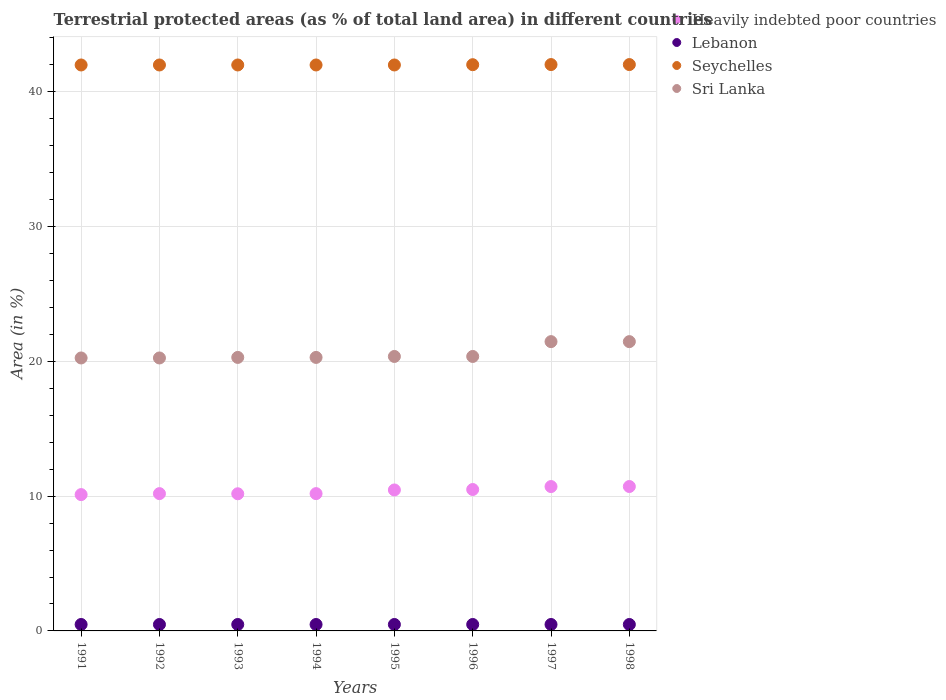Is the number of dotlines equal to the number of legend labels?
Give a very brief answer. Yes. What is the percentage of terrestrial protected land in Lebanon in 1993?
Ensure brevity in your answer.  0.48. Across all years, what is the maximum percentage of terrestrial protected land in Lebanon?
Give a very brief answer. 0.48. Across all years, what is the minimum percentage of terrestrial protected land in Lebanon?
Your answer should be compact. 0.48. In which year was the percentage of terrestrial protected land in Seychelles maximum?
Your response must be concise. 1997. What is the total percentage of terrestrial protected land in Sri Lanka in the graph?
Your response must be concise. 164.75. What is the difference between the percentage of terrestrial protected land in Lebanon in 1994 and that in 1996?
Make the answer very short. 0. What is the difference between the percentage of terrestrial protected land in Seychelles in 1993 and the percentage of terrestrial protected land in Lebanon in 1996?
Offer a very short reply. 41.51. What is the average percentage of terrestrial protected land in Lebanon per year?
Make the answer very short. 0.48. In the year 1993, what is the difference between the percentage of terrestrial protected land in Sri Lanka and percentage of terrestrial protected land in Seychelles?
Your answer should be compact. -21.7. In how many years, is the percentage of terrestrial protected land in Lebanon greater than 36 %?
Make the answer very short. 0. What is the ratio of the percentage of terrestrial protected land in Heavily indebted poor countries in 1992 to that in 1993?
Your answer should be very brief. 1. Is the difference between the percentage of terrestrial protected land in Sri Lanka in 1994 and 1995 greater than the difference between the percentage of terrestrial protected land in Seychelles in 1994 and 1995?
Offer a terse response. No. What is the difference between the highest and the second highest percentage of terrestrial protected land in Heavily indebted poor countries?
Your answer should be compact. 0. Is the sum of the percentage of terrestrial protected land in Sri Lanka in 1992 and 1997 greater than the maximum percentage of terrestrial protected land in Lebanon across all years?
Provide a short and direct response. Yes. Is it the case that in every year, the sum of the percentage of terrestrial protected land in Sri Lanka and percentage of terrestrial protected land in Heavily indebted poor countries  is greater than the percentage of terrestrial protected land in Seychelles?
Your answer should be very brief. No. Is the percentage of terrestrial protected land in Seychelles strictly greater than the percentage of terrestrial protected land in Heavily indebted poor countries over the years?
Ensure brevity in your answer.  Yes. How many years are there in the graph?
Keep it short and to the point. 8. What is the difference between two consecutive major ticks on the Y-axis?
Offer a very short reply. 10. How many legend labels are there?
Provide a short and direct response. 4. How are the legend labels stacked?
Offer a terse response. Vertical. What is the title of the graph?
Provide a short and direct response. Terrestrial protected areas (as % of total land area) in different countries. Does "Malawi" appear as one of the legend labels in the graph?
Your answer should be compact. No. What is the label or title of the Y-axis?
Provide a short and direct response. Area (in %). What is the Area (in %) of Heavily indebted poor countries in 1991?
Offer a very short reply. 10.11. What is the Area (in %) of Lebanon in 1991?
Your answer should be very brief. 0.48. What is the Area (in %) in Seychelles in 1991?
Offer a very short reply. 41.99. What is the Area (in %) in Sri Lanka in 1991?
Provide a short and direct response. 20.25. What is the Area (in %) of Heavily indebted poor countries in 1992?
Keep it short and to the point. 10.19. What is the Area (in %) in Lebanon in 1992?
Provide a succinct answer. 0.48. What is the Area (in %) in Seychelles in 1992?
Your answer should be compact. 41.99. What is the Area (in %) in Sri Lanka in 1992?
Offer a very short reply. 20.25. What is the Area (in %) in Heavily indebted poor countries in 1993?
Provide a succinct answer. 10.18. What is the Area (in %) of Lebanon in 1993?
Keep it short and to the point. 0.48. What is the Area (in %) in Seychelles in 1993?
Give a very brief answer. 41.99. What is the Area (in %) of Sri Lanka in 1993?
Your answer should be compact. 20.29. What is the Area (in %) in Heavily indebted poor countries in 1994?
Give a very brief answer. 10.19. What is the Area (in %) of Lebanon in 1994?
Your answer should be compact. 0.48. What is the Area (in %) of Seychelles in 1994?
Make the answer very short. 41.99. What is the Area (in %) of Sri Lanka in 1994?
Offer a terse response. 20.29. What is the Area (in %) of Heavily indebted poor countries in 1995?
Provide a short and direct response. 10.46. What is the Area (in %) of Lebanon in 1995?
Offer a terse response. 0.48. What is the Area (in %) in Seychelles in 1995?
Provide a succinct answer. 41.99. What is the Area (in %) in Sri Lanka in 1995?
Make the answer very short. 20.36. What is the Area (in %) in Heavily indebted poor countries in 1996?
Offer a very short reply. 10.49. What is the Area (in %) in Lebanon in 1996?
Offer a very short reply. 0.48. What is the Area (in %) in Seychelles in 1996?
Your response must be concise. 42.01. What is the Area (in %) of Sri Lanka in 1996?
Your answer should be very brief. 20.36. What is the Area (in %) of Heavily indebted poor countries in 1997?
Offer a very short reply. 10.71. What is the Area (in %) of Lebanon in 1997?
Offer a terse response. 0.48. What is the Area (in %) of Seychelles in 1997?
Ensure brevity in your answer.  42.02. What is the Area (in %) of Sri Lanka in 1997?
Make the answer very short. 21.46. What is the Area (in %) of Heavily indebted poor countries in 1998?
Provide a short and direct response. 10.71. What is the Area (in %) in Lebanon in 1998?
Offer a very short reply. 0.48. What is the Area (in %) of Seychelles in 1998?
Make the answer very short. 42.02. What is the Area (in %) of Sri Lanka in 1998?
Provide a short and direct response. 21.46. Across all years, what is the maximum Area (in %) in Heavily indebted poor countries?
Provide a succinct answer. 10.71. Across all years, what is the maximum Area (in %) of Lebanon?
Ensure brevity in your answer.  0.48. Across all years, what is the maximum Area (in %) of Seychelles?
Offer a terse response. 42.02. Across all years, what is the maximum Area (in %) in Sri Lanka?
Your response must be concise. 21.46. Across all years, what is the minimum Area (in %) of Heavily indebted poor countries?
Make the answer very short. 10.11. Across all years, what is the minimum Area (in %) of Lebanon?
Ensure brevity in your answer.  0.48. Across all years, what is the minimum Area (in %) in Seychelles?
Give a very brief answer. 41.99. Across all years, what is the minimum Area (in %) of Sri Lanka?
Your answer should be very brief. 20.25. What is the total Area (in %) of Heavily indebted poor countries in the graph?
Make the answer very short. 83.04. What is the total Area (in %) of Lebanon in the graph?
Ensure brevity in your answer.  3.82. What is the total Area (in %) of Seychelles in the graph?
Make the answer very short. 336.02. What is the total Area (in %) of Sri Lanka in the graph?
Ensure brevity in your answer.  164.75. What is the difference between the Area (in %) of Heavily indebted poor countries in 1991 and that in 1992?
Offer a terse response. -0.07. What is the difference between the Area (in %) in Heavily indebted poor countries in 1991 and that in 1993?
Offer a terse response. -0.06. What is the difference between the Area (in %) in Sri Lanka in 1991 and that in 1993?
Offer a very short reply. -0.04. What is the difference between the Area (in %) of Heavily indebted poor countries in 1991 and that in 1994?
Offer a terse response. -0.07. What is the difference between the Area (in %) of Lebanon in 1991 and that in 1994?
Give a very brief answer. 0. What is the difference between the Area (in %) of Seychelles in 1991 and that in 1994?
Your response must be concise. 0. What is the difference between the Area (in %) of Sri Lanka in 1991 and that in 1994?
Offer a terse response. -0.04. What is the difference between the Area (in %) of Heavily indebted poor countries in 1991 and that in 1995?
Ensure brevity in your answer.  -0.35. What is the difference between the Area (in %) in Seychelles in 1991 and that in 1995?
Offer a terse response. 0. What is the difference between the Area (in %) in Sri Lanka in 1991 and that in 1995?
Give a very brief answer. -0.11. What is the difference between the Area (in %) of Heavily indebted poor countries in 1991 and that in 1996?
Make the answer very short. -0.38. What is the difference between the Area (in %) in Seychelles in 1991 and that in 1996?
Provide a succinct answer. -0.02. What is the difference between the Area (in %) of Sri Lanka in 1991 and that in 1996?
Make the answer very short. -0.11. What is the difference between the Area (in %) in Heavily indebted poor countries in 1991 and that in 1997?
Provide a short and direct response. -0.6. What is the difference between the Area (in %) in Lebanon in 1991 and that in 1997?
Give a very brief answer. 0. What is the difference between the Area (in %) of Seychelles in 1991 and that in 1997?
Give a very brief answer. -0.03. What is the difference between the Area (in %) in Sri Lanka in 1991 and that in 1997?
Your response must be concise. -1.21. What is the difference between the Area (in %) of Lebanon in 1991 and that in 1998?
Your answer should be very brief. 0. What is the difference between the Area (in %) in Seychelles in 1991 and that in 1998?
Give a very brief answer. -0.03. What is the difference between the Area (in %) in Sri Lanka in 1991 and that in 1998?
Your response must be concise. -1.21. What is the difference between the Area (in %) of Heavily indebted poor countries in 1992 and that in 1993?
Make the answer very short. 0.01. What is the difference between the Area (in %) of Lebanon in 1992 and that in 1993?
Provide a short and direct response. 0. What is the difference between the Area (in %) of Seychelles in 1992 and that in 1993?
Your answer should be compact. 0. What is the difference between the Area (in %) in Sri Lanka in 1992 and that in 1993?
Provide a succinct answer. -0.04. What is the difference between the Area (in %) in Lebanon in 1992 and that in 1994?
Make the answer very short. 0. What is the difference between the Area (in %) in Seychelles in 1992 and that in 1994?
Your answer should be very brief. 0. What is the difference between the Area (in %) of Sri Lanka in 1992 and that in 1994?
Give a very brief answer. -0.04. What is the difference between the Area (in %) of Heavily indebted poor countries in 1992 and that in 1995?
Make the answer very short. -0.27. What is the difference between the Area (in %) in Lebanon in 1992 and that in 1995?
Provide a short and direct response. 0. What is the difference between the Area (in %) in Seychelles in 1992 and that in 1995?
Ensure brevity in your answer.  0. What is the difference between the Area (in %) in Sri Lanka in 1992 and that in 1995?
Offer a terse response. -0.11. What is the difference between the Area (in %) of Heavily indebted poor countries in 1992 and that in 1996?
Offer a very short reply. -0.3. What is the difference between the Area (in %) in Seychelles in 1992 and that in 1996?
Your answer should be compact. -0.02. What is the difference between the Area (in %) of Sri Lanka in 1992 and that in 1996?
Your answer should be compact. -0.11. What is the difference between the Area (in %) of Heavily indebted poor countries in 1992 and that in 1997?
Keep it short and to the point. -0.52. What is the difference between the Area (in %) of Seychelles in 1992 and that in 1997?
Offer a very short reply. -0.03. What is the difference between the Area (in %) in Sri Lanka in 1992 and that in 1997?
Provide a short and direct response. -1.21. What is the difference between the Area (in %) in Heavily indebted poor countries in 1992 and that in 1998?
Your answer should be compact. -0.53. What is the difference between the Area (in %) in Lebanon in 1992 and that in 1998?
Offer a terse response. 0. What is the difference between the Area (in %) of Seychelles in 1992 and that in 1998?
Provide a succinct answer. -0.03. What is the difference between the Area (in %) of Sri Lanka in 1992 and that in 1998?
Make the answer very short. -1.21. What is the difference between the Area (in %) in Heavily indebted poor countries in 1993 and that in 1994?
Provide a succinct answer. -0.01. What is the difference between the Area (in %) in Lebanon in 1993 and that in 1994?
Provide a short and direct response. 0. What is the difference between the Area (in %) in Seychelles in 1993 and that in 1994?
Keep it short and to the point. 0. What is the difference between the Area (in %) in Heavily indebted poor countries in 1993 and that in 1995?
Your answer should be compact. -0.28. What is the difference between the Area (in %) in Sri Lanka in 1993 and that in 1995?
Ensure brevity in your answer.  -0.07. What is the difference between the Area (in %) in Heavily indebted poor countries in 1993 and that in 1996?
Make the answer very short. -0.32. What is the difference between the Area (in %) in Seychelles in 1993 and that in 1996?
Keep it short and to the point. -0.02. What is the difference between the Area (in %) in Sri Lanka in 1993 and that in 1996?
Provide a short and direct response. -0.07. What is the difference between the Area (in %) in Heavily indebted poor countries in 1993 and that in 1997?
Offer a very short reply. -0.54. What is the difference between the Area (in %) of Lebanon in 1993 and that in 1997?
Make the answer very short. 0. What is the difference between the Area (in %) of Seychelles in 1993 and that in 1997?
Your response must be concise. -0.03. What is the difference between the Area (in %) of Sri Lanka in 1993 and that in 1997?
Ensure brevity in your answer.  -1.17. What is the difference between the Area (in %) of Heavily indebted poor countries in 1993 and that in 1998?
Provide a short and direct response. -0.54. What is the difference between the Area (in %) of Seychelles in 1993 and that in 1998?
Your response must be concise. -0.03. What is the difference between the Area (in %) in Sri Lanka in 1993 and that in 1998?
Your answer should be compact. -1.17. What is the difference between the Area (in %) in Heavily indebted poor countries in 1994 and that in 1995?
Provide a short and direct response. -0.27. What is the difference between the Area (in %) in Lebanon in 1994 and that in 1995?
Make the answer very short. 0. What is the difference between the Area (in %) of Sri Lanka in 1994 and that in 1995?
Your response must be concise. -0.07. What is the difference between the Area (in %) of Heavily indebted poor countries in 1994 and that in 1996?
Keep it short and to the point. -0.3. What is the difference between the Area (in %) of Lebanon in 1994 and that in 1996?
Your answer should be very brief. 0. What is the difference between the Area (in %) of Seychelles in 1994 and that in 1996?
Your answer should be very brief. -0.02. What is the difference between the Area (in %) of Sri Lanka in 1994 and that in 1996?
Offer a very short reply. -0.07. What is the difference between the Area (in %) in Heavily indebted poor countries in 1994 and that in 1997?
Ensure brevity in your answer.  -0.52. What is the difference between the Area (in %) of Seychelles in 1994 and that in 1997?
Provide a short and direct response. -0.03. What is the difference between the Area (in %) in Sri Lanka in 1994 and that in 1997?
Your response must be concise. -1.17. What is the difference between the Area (in %) in Heavily indebted poor countries in 1994 and that in 1998?
Provide a short and direct response. -0.53. What is the difference between the Area (in %) of Seychelles in 1994 and that in 1998?
Your response must be concise. -0.03. What is the difference between the Area (in %) in Sri Lanka in 1994 and that in 1998?
Ensure brevity in your answer.  -1.17. What is the difference between the Area (in %) in Heavily indebted poor countries in 1995 and that in 1996?
Offer a terse response. -0.03. What is the difference between the Area (in %) in Lebanon in 1995 and that in 1996?
Provide a succinct answer. 0. What is the difference between the Area (in %) in Seychelles in 1995 and that in 1996?
Keep it short and to the point. -0.02. What is the difference between the Area (in %) of Sri Lanka in 1995 and that in 1996?
Make the answer very short. 0. What is the difference between the Area (in %) of Heavily indebted poor countries in 1995 and that in 1997?
Your response must be concise. -0.25. What is the difference between the Area (in %) in Seychelles in 1995 and that in 1997?
Offer a terse response. -0.03. What is the difference between the Area (in %) of Sri Lanka in 1995 and that in 1997?
Provide a short and direct response. -1.1. What is the difference between the Area (in %) of Heavily indebted poor countries in 1995 and that in 1998?
Offer a very short reply. -0.25. What is the difference between the Area (in %) in Lebanon in 1995 and that in 1998?
Your response must be concise. 0. What is the difference between the Area (in %) of Seychelles in 1995 and that in 1998?
Your response must be concise. -0.03. What is the difference between the Area (in %) in Sri Lanka in 1995 and that in 1998?
Your response must be concise. -1.1. What is the difference between the Area (in %) in Heavily indebted poor countries in 1996 and that in 1997?
Provide a short and direct response. -0.22. What is the difference between the Area (in %) of Seychelles in 1996 and that in 1997?
Provide a succinct answer. -0.01. What is the difference between the Area (in %) in Sri Lanka in 1996 and that in 1997?
Your answer should be compact. -1.1. What is the difference between the Area (in %) in Heavily indebted poor countries in 1996 and that in 1998?
Offer a terse response. -0.22. What is the difference between the Area (in %) of Lebanon in 1996 and that in 1998?
Ensure brevity in your answer.  0. What is the difference between the Area (in %) of Seychelles in 1996 and that in 1998?
Keep it short and to the point. -0.01. What is the difference between the Area (in %) of Sri Lanka in 1996 and that in 1998?
Offer a terse response. -1.1. What is the difference between the Area (in %) of Heavily indebted poor countries in 1997 and that in 1998?
Offer a terse response. -0. What is the difference between the Area (in %) of Lebanon in 1997 and that in 1998?
Your answer should be very brief. 0. What is the difference between the Area (in %) in Heavily indebted poor countries in 1991 and the Area (in %) in Lebanon in 1992?
Keep it short and to the point. 9.64. What is the difference between the Area (in %) of Heavily indebted poor countries in 1991 and the Area (in %) of Seychelles in 1992?
Your answer should be very brief. -31.88. What is the difference between the Area (in %) of Heavily indebted poor countries in 1991 and the Area (in %) of Sri Lanka in 1992?
Give a very brief answer. -10.14. What is the difference between the Area (in %) in Lebanon in 1991 and the Area (in %) in Seychelles in 1992?
Offer a terse response. -41.51. What is the difference between the Area (in %) in Lebanon in 1991 and the Area (in %) in Sri Lanka in 1992?
Provide a succinct answer. -19.78. What is the difference between the Area (in %) in Seychelles in 1991 and the Area (in %) in Sri Lanka in 1992?
Provide a short and direct response. 21.74. What is the difference between the Area (in %) of Heavily indebted poor countries in 1991 and the Area (in %) of Lebanon in 1993?
Keep it short and to the point. 9.64. What is the difference between the Area (in %) of Heavily indebted poor countries in 1991 and the Area (in %) of Seychelles in 1993?
Provide a short and direct response. -31.88. What is the difference between the Area (in %) of Heavily indebted poor countries in 1991 and the Area (in %) of Sri Lanka in 1993?
Keep it short and to the point. -10.18. What is the difference between the Area (in %) of Lebanon in 1991 and the Area (in %) of Seychelles in 1993?
Your answer should be very brief. -41.51. What is the difference between the Area (in %) of Lebanon in 1991 and the Area (in %) of Sri Lanka in 1993?
Keep it short and to the point. -19.82. What is the difference between the Area (in %) of Seychelles in 1991 and the Area (in %) of Sri Lanka in 1993?
Provide a succinct answer. 21.7. What is the difference between the Area (in %) in Heavily indebted poor countries in 1991 and the Area (in %) in Lebanon in 1994?
Your answer should be compact. 9.64. What is the difference between the Area (in %) of Heavily indebted poor countries in 1991 and the Area (in %) of Seychelles in 1994?
Provide a short and direct response. -31.88. What is the difference between the Area (in %) of Heavily indebted poor countries in 1991 and the Area (in %) of Sri Lanka in 1994?
Provide a succinct answer. -10.18. What is the difference between the Area (in %) of Lebanon in 1991 and the Area (in %) of Seychelles in 1994?
Offer a very short reply. -41.51. What is the difference between the Area (in %) of Lebanon in 1991 and the Area (in %) of Sri Lanka in 1994?
Your answer should be very brief. -19.82. What is the difference between the Area (in %) in Seychelles in 1991 and the Area (in %) in Sri Lanka in 1994?
Give a very brief answer. 21.7. What is the difference between the Area (in %) of Heavily indebted poor countries in 1991 and the Area (in %) of Lebanon in 1995?
Provide a short and direct response. 9.64. What is the difference between the Area (in %) in Heavily indebted poor countries in 1991 and the Area (in %) in Seychelles in 1995?
Ensure brevity in your answer.  -31.88. What is the difference between the Area (in %) of Heavily indebted poor countries in 1991 and the Area (in %) of Sri Lanka in 1995?
Your answer should be compact. -10.25. What is the difference between the Area (in %) of Lebanon in 1991 and the Area (in %) of Seychelles in 1995?
Provide a succinct answer. -41.51. What is the difference between the Area (in %) of Lebanon in 1991 and the Area (in %) of Sri Lanka in 1995?
Offer a terse response. -19.89. What is the difference between the Area (in %) in Seychelles in 1991 and the Area (in %) in Sri Lanka in 1995?
Provide a short and direct response. 21.63. What is the difference between the Area (in %) in Heavily indebted poor countries in 1991 and the Area (in %) in Lebanon in 1996?
Make the answer very short. 9.64. What is the difference between the Area (in %) in Heavily indebted poor countries in 1991 and the Area (in %) in Seychelles in 1996?
Keep it short and to the point. -31.9. What is the difference between the Area (in %) of Heavily indebted poor countries in 1991 and the Area (in %) of Sri Lanka in 1996?
Ensure brevity in your answer.  -10.25. What is the difference between the Area (in %) of Lebanon in 1991 and the Area (in %) of Seychelles in 1996?
Keep it short and to the point. -41.54. What is the difference between the Area (in %) in Lebanon in 1991 and the Area (in %) in Sri Lanka in 1996?
Your answer should be compact. -19.89. What is the difference between the Area (in %) in Seychelles in 1991 and the Area (in %) in Sri Lanka in 1996?
Offer a very short reply. 21.63. What is the difference between the Area (in %) of Heavily indebted poor countries in 1991 and the Area (in %) of Lebanon in 1997?
Keep it short and to the point. 9.64. What is the difference between the Area (in %) in Heavily indebted poor countries in 1991 and the Area (in %) in Seychelles in 1997?
Keep it short and to the point. -31.91. What is the difference between the Area (in %) of Heavily indebted poor countries in 1991 and the Area (in %) of Sri Lanka in 1997?
Give a very brief answer. -11.35. What is the difference between the Area (in %) of Lebanon in 1991 and the Area (in %) of Seychelles in 1997?
Ensure brevity in your answer.  -41.54. What is the difference between the Area (in %) of Lebanon in 1991 and the Area (in %) of Sri Lanka in 1997?
Your answer should be very brief. -20.99. What is the difference between the Area (in %) in Seychelles in 1991 and the Area (in %) in Sri Lanka in 1997?
Ensure brevity in your answer.  20.53. What is the difference between the Area (in %) in Heavily indebted poor countries in 1991 and the Area (in %) in Lebanon in 1998?
Offer a very short reply. 9.64. What is the difference between the Area (in %) in Heavily indebted poor countries in 1991 and the Area (in %) in Seychelles in 1998?
Give a very brief answer. -31.91. What is the difference between the Area (in %) of Heavily indebted poor countries in 1991 and the Area (in %) of Sri Lanka in 1998?
Make the answer very short. -11.35. What is the difference between the Area (in %) of Lebanon in 1991 and the Area (in %) of Seychelles in 1998?
Offer a very short reply. -41.54. What is the difference between the Area (in %) of Lebanon in 1991 and the Area (in %) of Sri Lanka in 1998?
Provide a succinct answer. -20.99. What is the difference between the Area (in %) of Seychelles in 1991 and the Area (in %) of Sri Lanka in 1998?
Your answer should be compact. 20.53. What is the difference between the Area (in %) of Heavily indebted poor countries in 1992 and the Area (in %) of Lebanon in 1993?
Give a very brief answer. 9.71. What is the difference between the Area (in %) of Heavily indebted poor countries in 1992 and the Area (in %) of Seychelles in 1993?
Offer a very short reply. -31.8. What is the difference between the Area (in %) in Heavily indebted poor countries in 1992 and the Area (in %) in Sri Lanka in 1993?
Your answer should be compact. -10.11. What is the difference between the Area (in %) of Lebanon in 1992 and the Area (in %) of Seychelles in 1993?
Provide a short and direct response. -41.51. What is the difference between the Area (in %) in Lebanon in 1992 and the Area (in %) in Sri Lanka in 1993?
Provide a short and direct response. -19.82. What is the difference between the Area (in %) in Seychelles in 1992 and the Area (in %) in Sri Lanka in 1993?
Make the answer very short. 21.7. What is the difference between the Area (in %) of Heavily indebted poor countries in 1992 and the Area (in %) of Lebanon in 1994?
Offer a very short reply. 9.71. What is the difference between the Area (in %) of Heavily indebted poor countries in 1992 and the Area (in %) of Seychelles in 1994?
Provide a succinct answer. -31.8. What is the difference between the Area (in %) in Heavily indebted poor countries in 1992 and the Area (in %) in Sri Lanka in 1994?
Offer a very short reply. -10.11. What is the difference between the Area (in %) in Lebanon in 1992 and the Area (in %) in Seychelles in 1994?
Make the answer very short. -41.51. What is the difference between the Area (in %) in Lebanon in 1992 and the Area (in %) in Sri Lanka in 1994?
Your answer should be very brief. -19.82. What is the difference between the Area (in %) in Seychelles in 1992 and the Area (in %) in Sri Lanka in 1994?
Provide a succinct answer. 21.7. What is the difference between the Area (in %) in Heavily indebted poor countries in 1992 and the Area (in %) in Lebanon in 1995?
Give a very brief answer. 9.71. What is the difference between the Area (in %) in Heavily indebted poor countries in 1992 and the Area (in %) in Seychelles in 1995?
Your response must be concise. -31.8. What is the difference between the Area (in %) of Heavily indebted poor countries in 1992 and the Area (in %) of Sri Lanka in 1995?
Make the answer very short. -10.18. What is the difference between the Area (in %) in Lebanon in 1992 and the Area (in %) in Seychelles in 1995?
Provide a short and direct response. -41.51. What is the difference between the Area (in %) of Lebanon in 1992 and the Area (in %) of Sri Lanka in 1995?
Ensure brevity in your answer.  -19.89. What is the difference between the Area (in %) in Seychelles in 1992 and the Area (in %) in Sri Lanka in 1995?
Provide a short and direct response. 21.63. What is the difference between the Area (in %) in Heavily indebted poor countries in 1992 and the Area (in %) in Lebanon in 1996?
Your answer should be very brief. 9.71. What is the difference between the Area (in %) of Heavily indebted poor countries in 1992 and the Area (in %) of Seychelles in 1996?
Offer a terse response. -31.83. What is the difference between the Area (in %) of Heavily indebted poor countries in 1992 and the Area (in %) of Sri Lanka in 1996?
Give a very brief answer. -10.18. What is the difference between the Area (in %) of Lebanon in 1992 and the Area (in %) of Seychelles in 1996?
Give a very brief answer. -41.54. What is the difference between the Area (in %) of Lebanon in 1992 and the Area (in %) of Sri Lanka in 1996?
Your answer should be very brief. -19.89. What is the difference between the Area (in %) in Seychelles in 1992 and the Area (in %) in Sri Lanka in 1996?
Give a very brief answer. 21.63. What is the difference between the Area (in %) of Heavily indebted poor countries in 1992 and the Area (in %) of Lebanon in 1997?
Your answer should be compact. 9.71. What is the difference between the Area (in %) of Heavily indebted poor countries in 1992 and the Area (in %) of Seychelles in 1997?
Provide a short and direct response. -31.83. What is the difference between the Area (in %) in Heavily indebted poor countries in 1992 and the Area (in %) in Sri Lanka in 1997?
Provide a short and direct response. -11.28. What is the difference between the Area (in %) in Lebanon in 1992 and the Area (in %) in Seychelles in 1997?
Your response must be concise. -41.54. What is the difference between the Area (in %) in Lebanon in 1992 and the Area (in %) in Sri Lanka in 1997?
Ensure brevity in your answer.  -20.99. What is the difference between the Area (in %) in Seychelles in 1992 and the Area (in %) in Sri Lanka in 1997?
Offer a terse response. 20.53. What is the difference between the Area (in %) of Heavily indebted poor countries in 1992 and the Area (in %) of Lebanon in 1998?
Make the answer very short. 9.71. What is the difference between the Area (in %) of Heavily indebted poor countries in 1992 and the Area (in %) of Seychelles in 1998?
Your answer should be very brief. -31.83. What is the difference between the Area (in %) of Heavily indebted poor countries in 1992 and the Area (in %) of Sri Lanka in 1998?
Your response must be concise. -11.28. What is the difference between the Area (in %) in Lebanon in 1992 and the Area (in %) in Seychelles in 1998?
Your response must be concise. -41.54. What is the difference between the Area (in %) of Lebanon in 1992 and the Area (in %) of Sri Lanka in 1998?
Provide a succinct answer. -20.99. What is the difference between the Area (in %) of Seychelles in 1992 and the Area (in %) of Sri Lanka in 1998?
Offer a terse response. 20.53. What is the difference between the Area (in %) in Heavily indebted poor countries in 1993 and the Area (in %) in Lebanon in 1994?
Offer a very short reply. 9.7. What is the difference between the Area (in %) in Heavily indebted poor countries in 1993 and the Area (in %) in Seychelles in 1994?
Give a very brief answer. -31.82. What is the difference between the Area (in %) in Heavily indebted poor countries in 1993 and the Area (in %) in Sri Lanka in 1994?
Your response must be concise. -10.12. What is the difference between the Area (in %) in Lebanon in 1993 and the Area (in %) in Seychelles in 1994?
Keep it short and to the point. -41.51. What is the difference between the Area (in %) in Lebanon in 1993 and the Area (in %) in Sri Lanka in 1994?
Your answer should be compact. -19.82. What is the difference between the Area (in %) in Seychelles in 1993 and the Area (in %) in Sri Lanka in 1994?
Give a very brief answer. 21.7. What is the difference between the Area (in %) of Heavily indebted poor countries in 1993 and the Area (in %) of Lebanon in 1995?
Your answer should be compact. 9.7. What is the difference between the Area (in %) of Heavily indebted poor countries in 1993 and the Area (in %) of Seychelles in 1995?
Offer a very short reply. -31.82. What is the difference between the Area (in %) in Heavily indebted poor countries in 1993 and the Area (in %) in Sri Lanka in 1995?
Keep it short and to the point. -10.19. What is the difference between the Area (in %) in Lebanon in 1993 and the Area (in %) in Seychelles in 1995?
Your answer should be compact. -41.51. What is the difference between the Area (in %) of Lebanon in 1993 and the Area (in %) of Sri Lanka in 1995?
Your answer should be compact. -19.89. What is the difference between the Area (in %) of Seychelles in 1993 and the Area (in %) of Sri Lanka in 1995?
Keep it short and to the point. 21.63. What is the difference between the Area (in %) of Heavily indebted poor countries in 1993 and the Area (in %) of Lebanon in 1996?
Offer a very short reply. 9.7. What is the difference between the Area (in %) of Heavily indebted poor countries in 1993 and the Area (in %) of Seychelles in 1996?
Your answer should be compact. -31.84. What is the difference between the Area (in %) in Heavily indebted poor countries in 1993 and the Area (in %) in Sri Lanka in 1996?
Your answer should be very brief. -10.19. What is the difference between the Area (in %) in Lebanon in 1993 and the Area (in %) in Seychelles in 1996?
Give a very brief answer. -41.54. What is the difference between the Area (in %) of Lebanon in 1993 and the Area (in %) of Sri Lanka in 1996?
Keep it short and to the point. -19.89. What is the difference between the Area (in %) in Seychelles in 1993 and the Area (in %) in Sri Lanka in 1996?
Your answer should be very brief. 21.63. What is the difference between the Area (in %) in Heavily indebted poor countries in 1993 and the Area (in %) in Lebanon in 1997?
Give a very brief answer. 9.7. What is the difference between the Area (in %) of Heavily indebted poor countries in 1993 and the Area (in %) of Seychelles in 1997?
Offer a very short reply. -31.85. What is the difference between the Area (in %) of Heavily indebted poor countries in 1993 and the Area (in %) of Sri Lanka in 1997?
Offer a very short reply. -11.29. What is the difference between the Area (in %) of Lebanon in 1993 and the Area (in %) of Seychelles in 1997?
Provide a succinct answer. -41.54. What is the difference between the Area (in %) in Lebanon in 1993 and the Area (in %) in Sri Lanka in 1997?
Provide a succinct answer. -20.99. What is the difference between the Area (in %) in Seychelles in 1993 and the Area (in %) in Sri Lanka in 1997?
Your answer should be very brief. 20.53. What is the difference between the Area (in %) of Heavily indebted poor countries in 1993 and the Area (in %) of Lebanon in 1998?
Your response must be concise. 9.7. What is the difference between the Area (in %) in Heavily indebted poor countries in 1993 and the Area (in %) in Seychelles in 1998?
Make the answer very short. -31.85. What is the difference between the Area (in %) of Heavily indebted poor countries in 1993 and the Area (in %) of Sri Lanka in 1998?
Your answer should be compact. -11.29. What is the difference between the Area (in %) in Lebanon in 1993 and the Area (in %) in Seychelles in 1998?
Your response must be concise. -41.54. What is the difference between the Area (in %) of Lebanon in 1993 and the Area (in %) of Sri Lanka in 1998?
Provide a short and direct response. -20.99. What is the difference between the Area (in %) of Seychelles in 1993 and the Area (in %) of Sri Lanka in 1998?
Ensure brevity in your answer.  20.53. What is the difference between the Area (in %) in Heavily indebted poor countries in 1994 and the Area (in %) in Lebanon in 1995?
Your answer should be very brief. 9.71. What is the difference between the Area (in %) of Heavily indebted poor countries in 1994 and the Area (in %) of Seychelles in 1995?
Offer a terse response. -31.8. What is the difference between the Area (in %) in Heavily indebted poor countries in 1994 and the Area (in %) in Sri Lanka in 1995?
Keep it short and to the point. -10.18. What is the difference between the Area (in %) in Lebanon in 1994 and the Area (in %) in Seychelles in 1995?
Give a very brief answer. -41.51. What is the difference between the Area (in %) in Lebanon in 1994 and the Area (in %) in Sri Lanka in 1995?
Provide a short and direct response. -19.89. What is the difference between the Area (in %) of Seychelles in 1994 and the Area (in %) of Sri Lanka in 1995?
Your answer should be compact. 21.63. What is the difference between the Area (in %) in Heavily indebted poor countries in 1994 and the Area (in %) in Lebanon in 1996?
Your response must be concise. 9.71. What is the difference between the Area (in %) in Heavily indebted poor countries in 1994 and the Area (in %) in Seychelles in 1996?
Make the answer very short. -31.83. What is the difference between the Area (in %) of Heavily indebted poor countries in 1994 and the Area (in %) of Sri Lanka in 1996?
Provide a succinct answer. -10.18. What is the difference between the Area (in %) of Lebanon in 1994 and the Area (in %) of Seychelles in 1996?
Provide a succinct answer. -41.54. What is the difference between the Area (in %) of Lebanon in 1994 and the Area (in %) of Sri Lanka in 1996?
Your response must be concise. -19.89. What is the difference between the Area (in %) of Seychelles in 1994 and the Area (in %) of Sri Lanka in 1996?
Ensure brevity in your answer.  21.63. What is the difference between the Area (in %) in Heavily indebted poor countries in 1994 and the Area (in %) in Lebanon in 1997?
Ensure brevity in your answer.  9.71. What is the difference between the Area (in %) of Heavily indebted poor countries in 1994 and the Area (in %) of Seychelles in 1997?
Your response must be concise. -31.83. What is the difference between the Area (in %) in Heavily indebted poor countries in 1994 and the Area (in %) in Sri Lanka in 1997?
Your answer should be very brief. -11.28. What is the difference between the Area (in %) in Lebanon in 1994 and the Area (in %) in Seychelles in 1997?
Give a very brief answer. -41.54. What is the difference between the Area (in %) in Lebanon in 1994 and the Area (in %) in Sri Lanka in 1997?
Your answer should be very brief. -20.99. What is the difference between the Area (in %) of Seychelles in 1994 and the Area (in %) of Sri Lanka in 1997?
Keep it short and to the point. 20.53. What is the difference between the Area (in %) of Heavily indebted poor countries in 1994 and the Area (in %) of Lebanon in 1998?
Your answer should be very brief. 9.71. What is the difference between the Area (in %) of Heavily indebted poor countries in 1994 and the Area (in %) of Seychelles in 1998?
Make the answer very short. -31.83. What is the difference between the Area (in %) in Heavily indebted poor countries in 1994 and the Area (in %) in Sri Lanka in 1998?
Offer a very short reply. -11.28. What is the difference between the Area (in %) of Lebanon in 1994 and the Area (in %) of Seychelles in 1998?
Keep it short and to the point. -41.54. What is the difference between the Area (in %) in Lebanon in 1994 and the Area (in %) in Sri Lanka in 1998?
Ensure brevity in your answer.  -20.99. What is the difference between the Area (in %) of Seychelles in 1994 and the Area (in %) of Sri Lanka in 1998?
Give a very brief answer. 20.53. What is the difference between the Area (in %) in Heavily indebted poor countries in 1995 and the Area (in %) in Lebanon in 1996?
Your answer should be very brief. 9.98. What is the difference between the Area (in %) in Heavily indebted poor countries in 1995 and the Area (in %) in Seychelles in 1996?
Your answer should be very brief. -31.55. What is the difference between the Area (in %) in Heavily indebted poor countries in 1995 and the Area (in %) in Sri Lanka in 1996?
Make the answer very short. -9.9. What is the difference between the Area (in %) in Lebanon in 1995 and the Area (in %) in Seychelles in 1996?
Make the answer very short. -41.54. What is the difference between the Area (in %) in Lebanon in 1995 and the Area (in %) in Sri Lanka in 1996?
Offer a very short reply. -19.89. What is the difference between the Area (in %) in Seychelles in 1995 and the Area (in %) in Sri Lanka in 1996?
Give a very brief answer. 21.63. What is the difference between the Area (in %) of Heavily indebted poor countries in 1995 and the Area (in %) of Lebanon in 1997?
Offer a very short reply. 9.98. What is the difference between the Area (in %) in Heavily indebted poor countries in 1995 and the Area (in %) in Seychelles in 1997?
Keep it short and to the point. -31.56. What is the difference between the Area (in %) of Heavily indebted poor countries in 1995 and the Area (in %) of Sri Lanka in 1997?
Offer a very short reply. -11. What is the difference between the Area (in %) of Lebanon in 1995 and the Area (in %) of Seychelles in 1997?
Ensure brevity in your answer.  -41.54. What is the difference between the Area (in %) in Lebanon in 1995 and the Area (in %) in Sri Lanka in 1997?
Give a very brief answer. -20.99. What is the difference between the Area (in %) of Seychelles in 1995 and the Area (in %) of Sri Lanka in 1997?
Your answer should be very brief. 20.53. What is the difference between the Area (in %) of Heavily indebted poor countries in 1995 and the Area (in %) of Lebanon in 1998?
Give a very brief answer. 9.98. What is the difference between the Area (in %) of Heavily indebted poor countries in 1995 and the Area (in %) of Seychelles in 1998?
Your answer should be very brief. -31.56. What is the difference between the Area (in %) in Heavily indebted poor countries in 1995 and the Area (in %) in Sri Lanka in 1998?
Your answer should be very brief. -11. What is the difference between the Area (in %) of Lebanon in 1995 and the Area (in %) of Seychelles in 1998?
Your answer should be very brief. -41.54. What is the difference between the Area (in %) of Lebanon in 1995 and the Area (in %) of Sri Lanka in 1998?
Provide a succinct answer. -20.99. What is the difference between the Area (in %) in Seychelles in 1995 and the Area (in %) in Sri Lanka in 1998?
Offer a terse response. 20.53. What is the difference between the Area (in %) in Heavily indebted poor countries in 1996 and the Area (in %) in Lebanon in 1997?
Your answer should be very brief. 10.01. What is the difference between the Area (in %) of Heavily indebted poor countries in 1996 and the Area (in %) of Seychelles in 1997?
Your answer should be compact. -31.53. What is the difference between the Area (in %) of Heavily indebted poor countries in 1996 and the Area (in %) of Sri Lanka in 1997?
Offer a terse response. -10.97. What is the difference between the Area (in %) in Lebanon in 1996 and the Area (in %) in Seychelles in 1997?
Your response must be concise. -41.54. What is the difference between the Area (in %) of Lebanon in 1996 and the Area (in %) of Sri Lanka in 1997?
Give a very brief answer. -20.99. What is the difference between the Area (in %) of Seychelles in 1996 and the Area (in %) of Sri Lanka in 1997?
Offer a very short reply. 20.55. What is the difference between the Area (in %) in Heavily indebted poor countries in 1996 and the Area (in %) in Lebanon in 1998?
Offer a very short reply. 10.01. What is the difference between the Area (in %) in Heavily indebted poor countries in 1996 and the Area (in %) in Seychelles in 1998?
Provide a short and direct response. -31.53. What is the difference between the Area (in %) of Heavily indebted poor countries in 1996 and the Area (in %) of Sri Lanka in 1998?
Provide a succinct answer. -10.97. What is the difference between the Area (in %) in Lebanon in 1996 and the Area (in %) in Seychelles in 1998?
Your answer should be very brief. -41.54. What is the difference between the Area (in %) of Lebanon in 1996 and the Area (in %) of Sri Lanka in 1998?
Give a very brief answer. -20.99. What is the difference between the Area (in %) in Seychelles in 1996 and the Area (in %) in Sri Lanka in 1998?
Provide a succinct answer. 20.55. What is the difference between the Area (in %) in Heavily indebted poor countries in 1997 and the Area (in %) in Lebanon in 1998?
Keep it short and to the point. 10.23. What is the difference between the Area (in %) of Heavily indebted poor countries in 1997 and the Area (in %) of Seychelles in 1998?
Your response must be concise. -31.31. What is the difference between the Area (in %) of Heavily indebted poor countries in 1997 and the Area (in %) of Sri Lanka in 1998?
Your answer should be compact. -10.75. What is the difference between the Area (in %) in Lebanon in 1997 and the Area (in %) in Seychelles in 1998?
Offer a very short reply. -41.54. What is the difference between the Area (in %) of Lebanon in 1997 and the Area (in %) of Sri Lanka in 1998?
Keep it short and to the point. -20.99. What is the difference between the Area (in %) of Seychelles in 1997 and the Area (in %) of Sri Lanka in 1998?
Provide a succinct answer. 20.56. What is the average Area (in %) of Heavily indebted poor countries per year?
Your response must be concise. 10.38. What is the average Area (in %) in Lebanon per year?
Ensure brevity in your answer.  0.48. What is the average Area (in %) of Seychelles per year?
Give a very brief answer. 42. What is the average Area (in %) of Sri Lanka per year?
Give a very brief answer. 20.59. In the year 1991, what is the difference between the Area (in %) of Heavily indebted poor countries and Area (in %) of Lebanon?
Keep it short and to the point. 9.64. In the year 1991, what is the difference between the Area (in %) in Heavily indebted poor countries and Area (in %) in Seychelles?
Give a very brief answer. -31.88. In the year 1991, what is the difference between the Area (in %) in Heavily indebted poor countries and Area (in %) in Sri Lanka?
Make the answer very short. -10.14. In the year 1991, what is the difference between the Area (in %) in Lebanon and Area (in %) in Seychelles?
Your response must be concise. -41.51. In the year 1991, what is the difference between the Area (in %) in Lebanon and Area (in %) in Sri Lanka?
Make the answer very short. -19.78. In the year 1991, what is the difference between the Area (in %) in Seychelles and Area (in %) in Sri Lanka?
Your answer should be very brief. 21.74. In the year 1992, what is the difference between the Area (in %) of Heavily indebted poor countries and Area (in %) of Lebanon?
Your answer should be very brief. 9.71. In the year 1992, what is the difference between the Area (in %) of Heavily indebted poor countries and Area (in %) of Seychelles?
Provide a short and direct response. -31.8. In the year 1992, what is the difference between the Area (in %) of Heavily indebted poor countries and Area (in %) of Sri Lanka?
Ensure brevity in your answer.  -10.07. In the year 1992, what is the difference between the Area (in %) in Lebanon and Area (in %) in Seychelles?
Ensure brevity in your answer.  -41.51. In the year 1992, what is the difference between the Area (in %) in Lebanon and Area (in %) in Sri Lanka?
Your response must be concise. -19.78. In the year 1992, what is the difference between the Area (in %) of Seychelles and Area (in %) of Sri Lanka?
Your answer should be very brief. 21.74. In the year 1993, what is the difference between the Area (in %) of Heavily indebted poor countries and Area (in %) of Lebanon?
Offer a terse response. 9.7. In the year 1993, what is the difference between the Area (in %) of Heavily indebted poor countries and Area (in %) of Seychelles?
Provide a succinct answer. -31.82. In the year 1993, what is the difference between the Area (in %) of Heavily indebted poor countries and Area (in %) of Sri Lanka?
Ensure brevity in your answer.  -10.12. In the year 1993, what is the difference between the Area (in %) in Lebanon and Area (in %) in Seychelles?
Offer a terse response. -41.51. In the year 1993, what is the difference between the Area (in %) of Lebanon and Area (in %) of Sri Lanka?
Give a very brief answer. -19.82. In the year 1993, what is the difference between the Area (in %) in Seychelles and Area (in %) in Sri Lanka?
Provide a succinct answer. 21.7. In the year 1994, what is the difference between the Area (in %) in Heavily indebted poor countries and Area (in %) in Lebanon?
Ensure brevity in your answer.  9.71. In the year 1994, what is the difference between the Area (in %) in Heavily indebted poor countries and Area (in %) in Seychelles?
Make the answer very short. -31.8. In the year 1994, what is the difference between the Area (in %) of Heavily indebted poor countries and Area (in %) of Sri Lanka?
Provide a short and direct response. -10.11. In the year 1994, what is the difference between the Area (in %) in Lebanon and Area (in %) in Seychelles?
Offer a terse response. -41.51. In the year 1994, what is the difference between the Area (in %) in Lebanon and Area (in %) in Sri Lanka?
Your answer should be compact. -19.82. In the year 1994, what is the difference between the Area (in %) in Seychelles and Area (in %) in Sri Lanka?
Your response must be concise. 21.7. In the year 1995, what is the difference between the Area (in %) in Heavily indebted poor countries and Area (in %) in Lebanon?
Provide a succinct answer. 9.98. In the year 1995, what is the difference between the Area (in %) of Heavily indebted poor countries and Area (in %) of Seychelles?
Keep it short and to the point. -31.53. In the year 1995, what is the difference between the Area (in %) of Heavily indebted poor countries and Area (in %) of Sri Lanka?
Offer a very short reply. -9.9. In the year 1995, what is the difference between the Area (in %) of Lebanon and Area (in %) of Seychelles?
Offer a terse response. -41.51. In the year 1995, what is the difference between the Area (in %) of Lebanon and Area (in %) of Sri Lanka?
Your answer should be compact. -19.89. In the year 1995, what is the difference between the Area (in %) in Seychelles and Area (in %) in Sri Lanka?
Offer a terse response. 21.63. In the year 1996, what is the difference between the Area (in %) in Heavily indebted poor countries and Area (in %) in Lebanon?
Provide a short and direct response. 10.01. In the year 1996, what is the difference between the Area (in %) of Heavily indebted poor countries and Area (in %) of Seychelles?
Make the answer very short. -31.52. In the year 1996, what is the difference between the Area (in %) in Heavily indebted poor countries and Area (in %) in Sri Lanka?
Give a very brief answer. -9.87. In the year 1996, what is the difference between the Area (in %) of Lebanon and Area (in %) of Seychelles?
Keep it short and to the point. -41.54. In the year 1996, what is the difference between the Area (in %) in Lebanon and Area (in %) in Sri Lanka?
Offer a terse response. -19.89. In the year 1996, what is the difference between the Area (in %) in Seychelles and Area (in %) in Sri Lanka?
Offer a terse response. 21.65. In the year 1997, what is the difference between the Area (in %) in Heavily indebted poor countries and Area (in %) in Lebanon?
Your response must be concise. 10.23. In the year 1997, what is the difference between the Area (in %) of Heavily indebted poor countries and Area (in %) of Seychelles?
Offer a very short reply. -31.31. In the year 1997, what is the difference between the Area (in %) of Heavily indebted poor countries and Area (in %) of Sri Lanka?
Offer a terse response. -10.75. In the year 1997, what is the difference between the Area (in %) of Lebanon and Area (in %) of Seychelles?
Your answer should be compact. -41.54. In the year 1997, what is the difference between the Area (in %) in Lebanon and Area (in %) in Sri Lanka?
Your response must be concise. -20.99. In the year 1997, what is the difference between the Area (in %) of Seychelles and Area (in %) of Sri Lanka?
Keep it short and to the point. 20.56. In the year 1998, what is the difference between the Area (in %) of Heavily indebted poor countries and Area (in %) of Lebanon?
Offer a very short reply. 10.24. In the year 1998, what is the difference between the Area (in %) of Heavily indebted poor countries and Area (in %) of Seychelles?
Provide a short and direct response. -31.31. In the year 1998, what is the difference between the Area (in %) of Heavily indebted poor countries and Area (in %) of Sri Lanka?
Provide a short and direct response. -10.75. In the year 1998, what is the difference between the Area (in %) in Lebanon and Area (in %) in Seychelles?
Your answer should be very brief. -41.54. In the year 1998, what is the difference between the Area (in %) of Lebanon and Area (in %) of Sri Lanka?
Your response must be concise. -20.99. In the year 1998, what is the difference between the Area (in %) of Seychelles and Area (in %) of Sri Lanka?
Give a very brief answer. 20.56. What is the ratio of the Area (in %) in Heavily indebted poor countries in 1991 to that in 1992?
Your answer should be compact. 0.99. What is the ratio of the Area (in %) in Seychelles in 1991 to that in 1992?
Give a very brief answer. 1. What is the ratio of the Area (in %) in Heavily indebted poor countries in 1991 to that in 1993?
Offer a very short reply. 0.99. What is the ratio of the Area (in %) in Heavily indebted poor countries in 1991 to that in 1994?
Your response must be concise. 0.99. What is the ratio of the Area (in %) of Heavily indebted poor countries in 1991 to that in 1995?
Offer a very short reply. 0.97. What is the ratio of the Area (in %) in Lebanon in 1991 to that in 1995?
Offer a terse response. 1. What is the ratio of the Area (in %) of Lebanon in 1991 to that in 1996?
Give a very brief answer. 1. What is the ratio of the Area (in %) of Sri Lanka in 1991 to that in 1996?
Make the answer very short. 0.99. What is the ratio of the Area (in %) in Heavily indebted poor countries in 1991 to that in 1997?
Ensure brevity in your answer.  0.94. What is the ratio of the Area (in %) of Lebanon in 1991 to that in 1997?
Offer a very short reply. 1. What is the ratio of the Area (in %) of Seychelles in 1991 to that in 1997?
Your response must be concise. 1. What is the ratio of the Area (in %) of Sri Lanka in 1991 to that in 1997?
Offer a terse response. 0.94. What is the ratio of the Area (in %) of Heavily indebted poor countries in 1991 to that in 1998?
Give a very brief answer. 0.94. What is the ratio of the Area (in %) of Lebanon in 1991 to that in 1998?
Keep it short and to the point. 1. What is the ratio of the Area (in %) of Sri Lanka in 1991 to that in 1998?
Give a very brief answer. 0.94. What is the ratio of the Area (in %) of Heavily indebted poor countries in 1992 to that in 1993?
Provide a short and direct response. 1. What is the ratio of the Area (in %) in Lebanon in 1992 to that in 1993?
Give a very brief answer. 1. What is the ratio of the Area (in %) in Seychelles in 1992 to that in 1993?
Your answer should be compact. 1. What is the ratio of the Area (in %) of Sri Lanka in 1992 to that in 1993?
Provide a short and direct response. 1. What is the ratio of the Area (in %) in Heavily indebted poor countries in 1992 to that in 1994?
Make the answer very short. 1. What is the ratio of the Area (in %) of Lebanon in 1992 to that in 1994?
Offer a very short reply. 1. What is the ratio of the Area (in %) in Seychelles in 1992 to that in 1995?
Offer a terse response. 1. What is the ratio of the Area (in %) of Sri Lanka in 1992 to that in 1995?
Keep it short and to the point. 0.99. What is the ratio of the Area (in %) of Lebanon in 1992 to that in 1996?
Give a very brief answer. 1. What is the ratio of the Area (in %) of Sri Lanka in 1992 to that in 1996?
Offer a terse response. 0.99. What is the ratio of the Area (in %) of Heavily indebted poor countries in 1992 to that in 1997?
Your response must be concise. 0.95. What is the ratio of the Area (in %) in Seychelles in 1992 to that in 1997?
Provide a short and direct response. 1. What is the ratio of the Area (in %) of Sri Lanka in 1992 to that in 1997?
Ensure brevity in your answer.  0.94. What is the ratio of the Area (in %) in Heavily indebted poor countries in 1992 to that in 1998?
Your response must be concise. 0.95. What is the ratio of the Area (in %) of Lebanon in 1992 to that in 1998?
Make the answer very short. 1. What is the ratio of the Area (in %) of Seychelles in 1992 to that in 1998?
Offer a very short reply. 1. What is the ratio of the Area (in %) of Sri Lanka in 1992 to that in 1998?
Offer a very short reply. 0.94. What is the ratio of the Area (in %) in Heavily indebted poor countries in 1993 to that in 1994?
Offer a terse response. 1. What is the ratio of the Area (in %) in Sri Lanka in 1993 to that in 1994?
Offer a very short reply. 1. What is the ratio of the Area (in %) in Heavily indebted poor countries in 1993 to that in 1995?
Ensure brevity in your answer.  0.97. What is the ratio of the Area (in %) in Lebanon in 1993 to that in 1995?
Ensure brevity in your answer.  1. What is the ratio of the Area (in %) in Sri Lanka in 1993 to that in 1995?
Your response must be concise. 1. What is the ratio of the Area (in %) in Heavily indebted poor countries in 1993 to that in 1996?
Your response must be concise. 0.97. What is the ratio of the Area (in %) of Sri Lanka in 1993 to that in 1996?
Provide a short and direct response. 1. What is the ratio of the Area (in %) in Heavily indebted poor countries in 1993 to that in 1997?
Ensure brevity in your answer.  0.95. What is the ratio of the Area (in %) of Seychelles in 1993 to that in 1997?
Your response must be concise. 1. What is the ratio of the Area (in %) in Sri Lanka in 1993 to that in 1997?
Provide a short and direct response. 0.95. What is the ratio of the Area (in %) of Heavily indebted poor countries in 1993 to that in 1998?
Offer a terse response. 0.95. What is the ratio of the Area (in %) in Lebanon in 1993 to that in 1998?
Offer a very short reply. 1. What is the ratio of the Area (in %) of Sri Lanka in 1993 to that in 1998?
Offer a terse response. 0.95. What is the ratio of the Area (in %) of Seychelles in 1994 to that in 1995?
Your answer should be compact. 1. What is the ratio of the Area (in %) of Heavily indebted poor countries in 1994 to that in 1996?
Your answer should be compact. 0.97. What is the ratio of the Area (in %) in Lebanon in 1994 to that in 1996?
Make the answer very short. 1. What is the ratio of the Area (in %) of Seychelles in 1994 to that in 1996?
Your answer should be very brief. 1. What is the ratio of the Area (in %) in Sri Lanka in 1994 to that in 1996?
Give a very brief answer. 1. What is the ratio of the Area (in %) in Heavily indebted poor countries in 1994 to that in 1997?
Offer a very short reply. 0.95. What is the ratio of the Area (in %) in Lebanon in 1994 to that in 1997?
Keep it short and to the point. 1. What is the ratio of the Area (in %) of Sri Lanka in 1994 to that in 1997?
Keep it short and to the point. 0.95. What is the ratio of the Area (in %) of Heavily indebted poor countries in 1994 to that in 1998?
Offer a terse response. 0.95. What is the ratio of the Area (in %) in Lebanon in 1994 to that in 1998?
Offer a very short reply. 1. What is the ratio of the Area (in %) of Seychelles in 1994 to that in 1998?
Your response must be concise. 1. What is the ratio of the Area (in %) in Sri Lanka in 1994 to that in 1998?
Keep it short and to the point. 0.95. What is the ratio of the Area (in %) of Lebanon in 1995 to that in 1996?
Ensure brevity in your answer.  1. What is the ratio of the Area (in %) in Seychelles in 1995 to that in 1996?
Ensure brevity in your answer.  1. What is the ratio of the Area (in %) in Heavily indebted poor countries in 1995 to that in 1997?
Offer a very short reply. 0.98. What is the ratio of the Area (in %) in Lebanon in 1995 to that in 1997?
Provide a succinct answer. 1. What is the ratio of the Area (in %) of Seychelles in 1995 to that in 1997?
Keep it short and to the point. 1. What is the ratio of the Area (in %) of Sri Lanka in 1995 to that in 1997?
Your answer should be very brief. 0.95. What is the ratio of the Area (in %) of Heavily indebted poor countries in 1995 to that in 1998?
Your answer should be compact. 0.98. What is the ratio of the Area (in %) in Seychelles in 1995 to that in 1998?
Ensure brevity in your answer.  1. What is the ratio of the Area (in %) in Sri Lanka in 1995 to that in 1998?
Your answer should be very brief. 0.95. What is the ratio of the Area (in %) in Heavily indebted poor countries in 1996 to that in 1997?
Your answer should be compact. 0.98. What is the ratio of the Area (in %) of Lebanon in 1996 to that in 1997?
Your answer should be very brief. 1. What is the ratio of the Area (in %) of Seychelles in 1996 to that in 1997?
Your response must be concise. 1. What is the ratio of the Area (in %) of Sri Lanka in 1996 to that in 1997?
Your answer should be very brief. 0.95. What is the ratio of the Area (in %) of Heavily indebted poor countries in 1996 to that in 1998?
Keep it short and to the point. 0.98. What is the ratio of the Area (in %) in Seychelles in 1996 to that in 1998?
Offer a terse response. 1. What is the ratio of the Area (in %) of Sri Lanka in 1996 to that in 1998?
Offer a very short reply. 0.95. What is the ratio of the Area (in %) in Lebanon in 1997 to that in 1998?
Make the answer very short. 1. What is the difference between the highest and the second highest Area (in %) in Heavily indebted poor countries?
Ensure brevity in your answer.  0. What is the difference between the highest and the second highest Area (in %) of Sri Lanka?
Provide a succinct answer. 0. What is the difference between the highest and the lowest Area (in %) of Lebanon?
Provide a succinct answer. 0. What is the difference between the highest and the lowest Area (in %) of Sri Lanka?
Give a very brief answer. 1.21. 